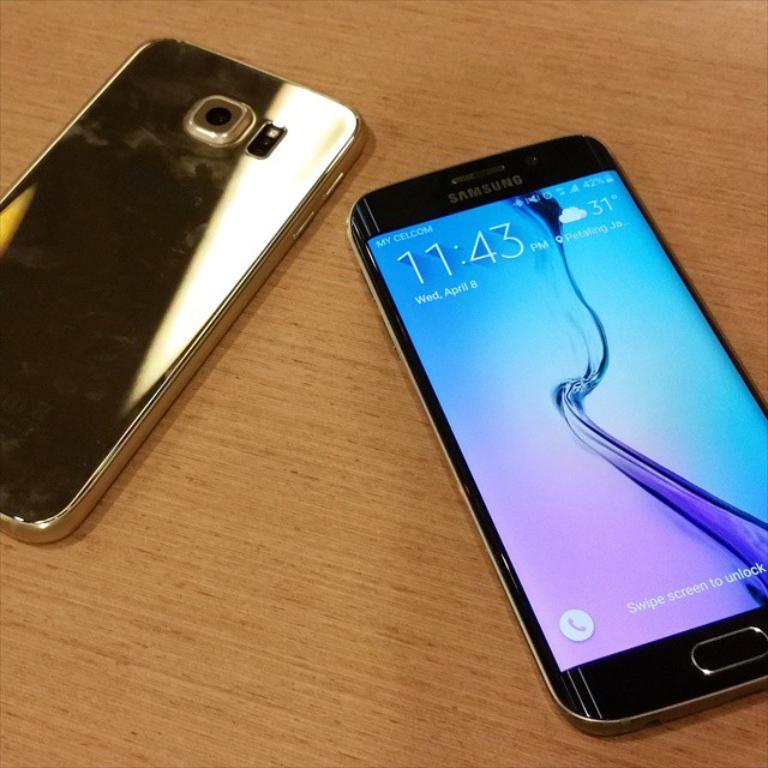What brand of smartphone is this?
Provide a succinct answer. Samsung. What time is it?
Ensure brevity in your answer.  11:43. 